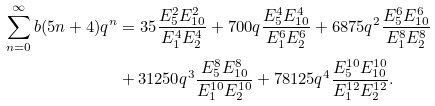Convert formula to latex. <formula><loc_0><loc_0><loc_500><loc_500>\sum _ { n = 0 } ^ { \infty } b ( 5 n + 4 ) q ^ { n } & = 3 5 \frac { E _ { 5 } ^ { 2 } E _ { 1 0 } ^ { 2 } } { E _ { 1 } ^ { 4 } E _ { 2 } ^ { 4 } } + 7 0 0 q \frac { E _ { 5 } ^ { 4 } E _ { 1 0 } ^ { 4 } } { E _ { 1 } ^ { 6 } E _ { 2 } ^ { 6 } } + 6 8 7 5 q ^ { 2 } \frac { E _ { 5 } ^ { 6 } E _ { 1 0 } ^ { 6 } } { E _ { 1 } ^ { 8 } E _ { 2 } ^ { 8 } } \\ & + 3 1 2 5 0 q ^ { 3 } \frac { E _ { 5 } ^ { 8 } E _ { 1 0 } ^ { 8 } } { E _ { 1 } ^ { 1 0 } E _ { 2 } ^ { 1 0 } } + 7 8 1 2 5 q ^ { 4 } \frac { E _ { 5 } ^ { 1 0 } E _ { 1 0 } ^ { 1 0 } } { E _ { 1 } ^ { 1 2 } E _ { 2 } ^ { 1 2 } } .</formula> 